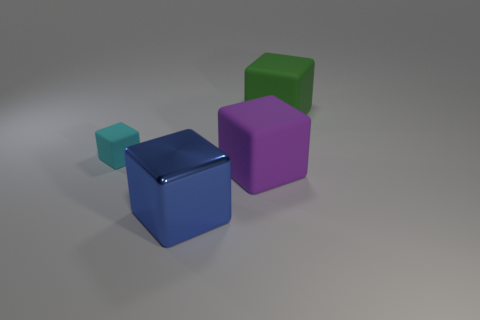There is a large cube that is behind the matte object to the left of the blue object; what is its color?
Keep it short and to the point. Green. There is a block to the left of the object that is in front of the matte object that is in front of the cyan matte cube; what is its size?
Your response must be concise. Small. Is the number of small objects that are behind the green block less than the number of big metal objects that are to the right of the large blue metallic block?
Ensure brevity in your answer.  No. How many tiny blocks are made of the same material as the big green block?
Provide a succinct answer. 1. There is a big matte cube that is left of the matte cube that is behind the tiny cyan matte cube; are there any cubes that are on the right side of it?
Keep it short and to the point. Yes. The green object that is made of the same material as the big purple block is what shape?
Ensure brevity in your answer.  Cube. Are there more red shiny balls than green rubber blocks?
Keep it short and to the point. No. There is a big purple thing; is it the same shape as the thing on the right side of the purple matte block?
Your answer should be compact. Yes. What is the material of the big purple thing?
Offer a terse response. Rubber. What is the color of the rubber object in front of the rubber block that is to the left of the big matte cube in front of the small cyan rubber thing?
Provide a succinct answer. Purple. 